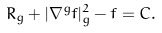<formula> <loc_0><loc_0><loc_500><loc_500>R _ { g } + | \nabla ^ { g } f | ^ { 2 } _ { g } - f = C .</formula> 